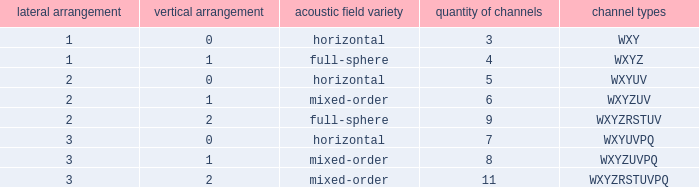If the channels is wxyzrstuvpq, what is the horizontal order? 3.0. 